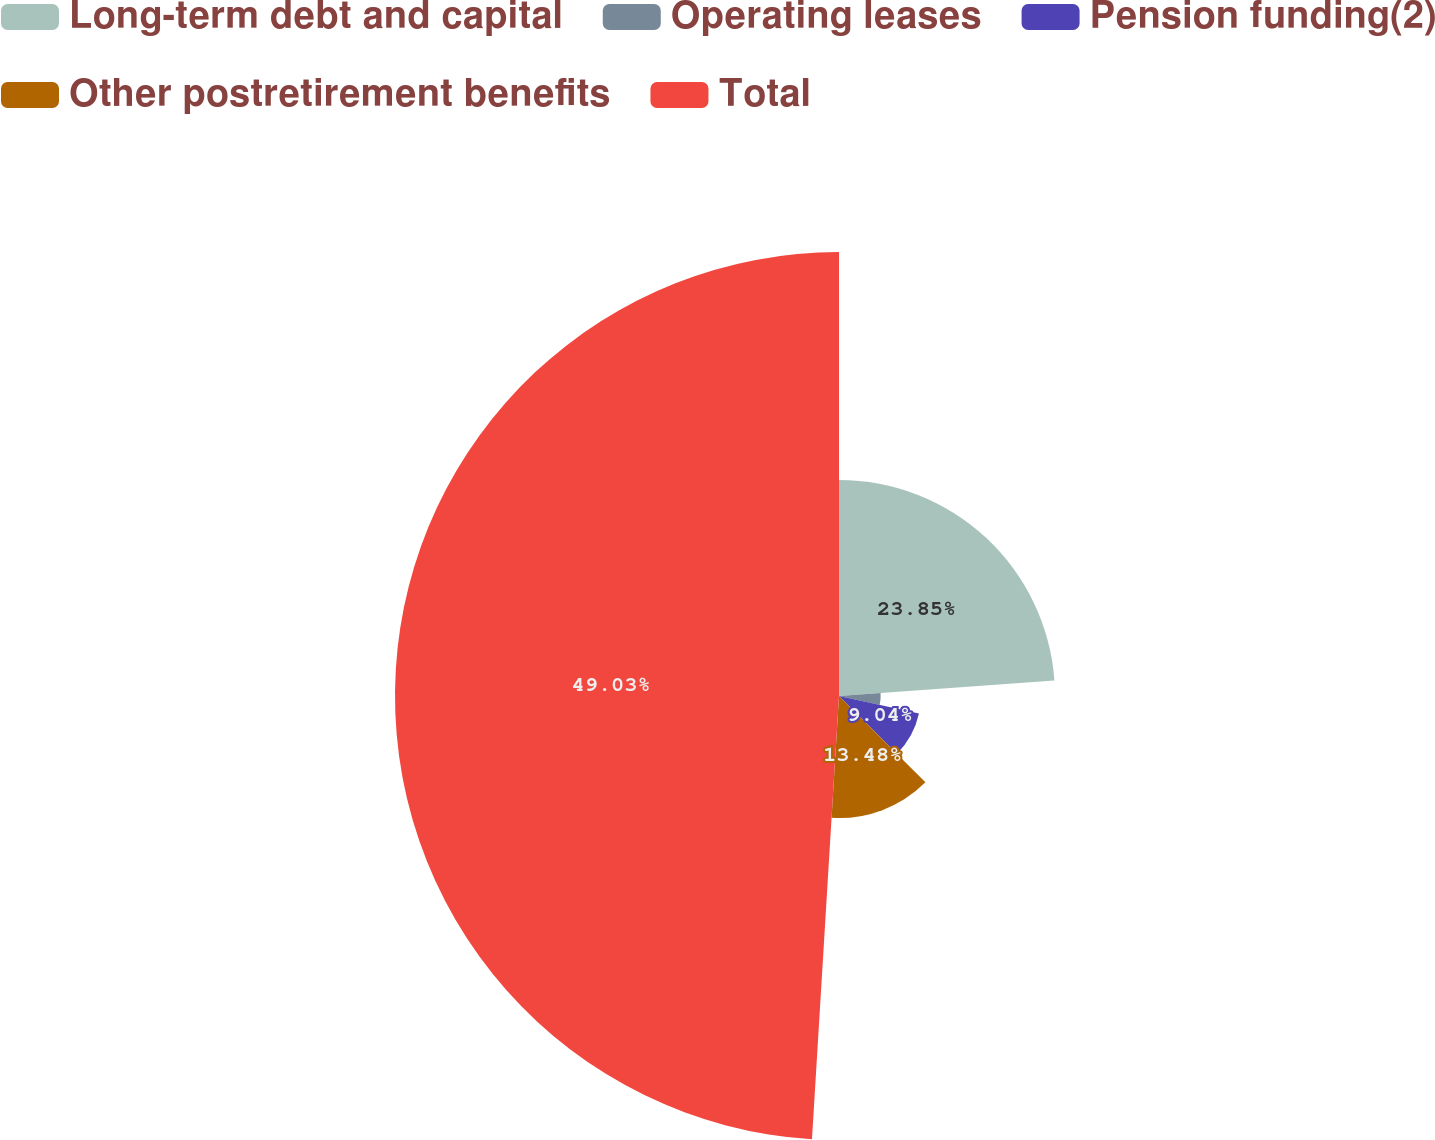<chart> <loc_0><loc_0><loc_500><loc_500><pie_chart><fcel>Long-term debt and capital<fcel>Operating leases<fcel>Pension funding(2)<fcel>Other postretirement benefits<fcel>Total<nl><fcel>23.85%<fcel>4.6%<fcel>9.04%<fcel>13.48%<fcel>49.03%<nl></chart> 